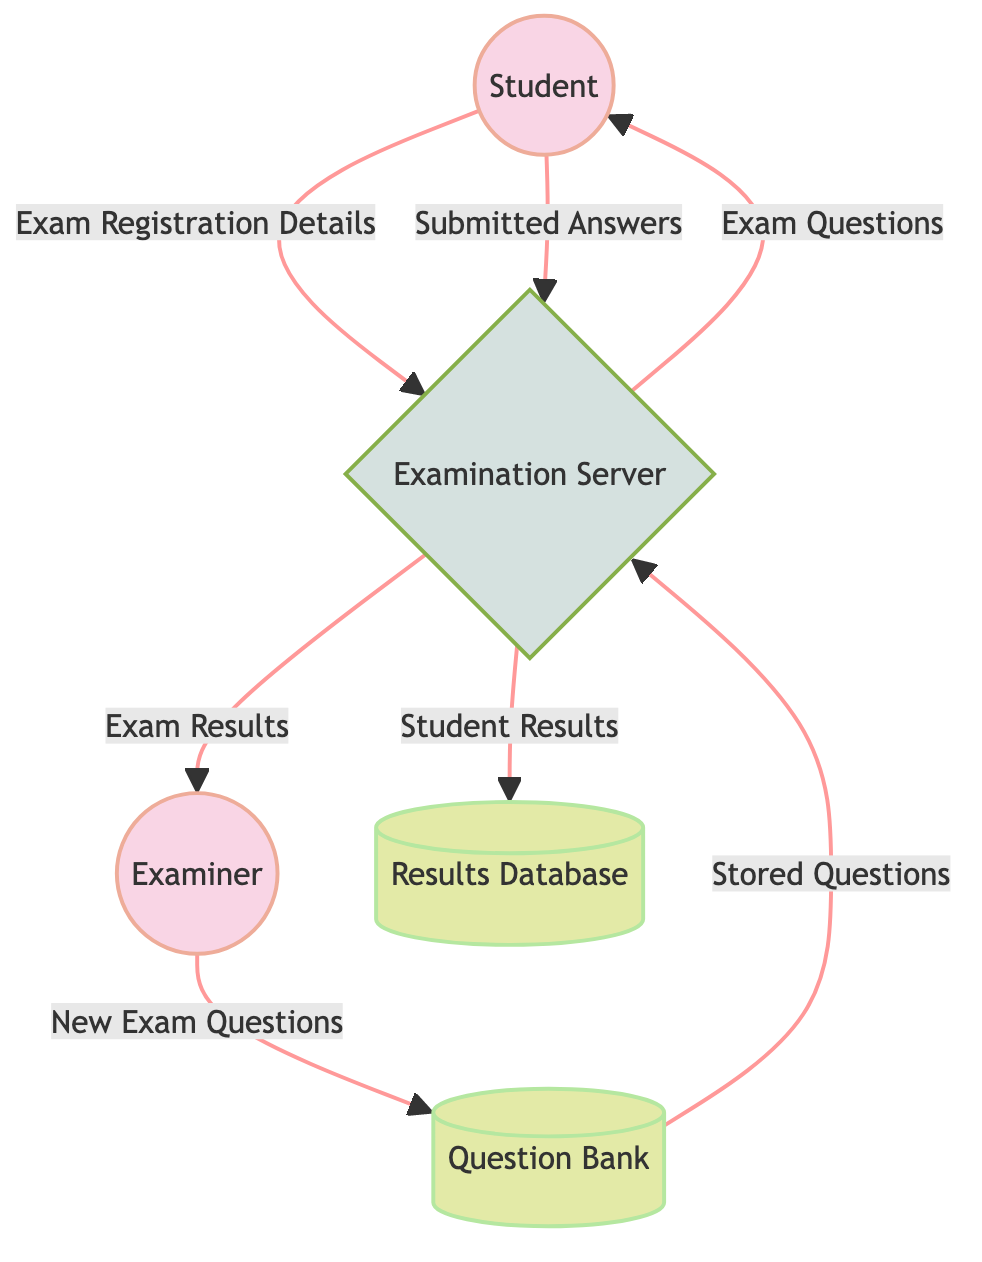What is the total number of external entities in the diagram? There are two external entities in the diagram: "Student" and "Examiner". These are distinctly marked in the diagram and fall under the category of external entities.
Answer: 2 What is the relationship between the "Examiner" and the "Question Bank"? The relationship involves the flow of "New Exam Questions" from the "Examiner" to the "Question Bank", indicating that the examiner contributes new questions.
Answer: New Exam Questions How many data flows are present in the diagram? By counting all the arrows leading from one node to another, we identify a total of six data flows in the diagram.
Answer: 6 What type of data does the "Examination Server" receive from the "Student"? The data received from the "Student" includes "Exam Registration Details" when the student registers to take the exam.
Answer: Exam Registration Details What does the "Examination Server" send to the "Results Database"? The "Examination Server" sends "Student Results" to the "Results Database" after evaluating the answers submitted by the student.
Answer: Student Results What happens to the "Stored Questions" coming from the "Question Bank"? The "Stored Questions" from the "Question Bank" are fed into the "Examination Server" for the creation of the exam, which is a critical process in the examination workflow.
Answer: Examination Server How does the "Examination Server" categorize its actions in the system? The "Examination Server" is classified as a process in this diagram, handling various activities like student registration and exam management, which is vital for the online examination system.
Answer: Process What type of node is "Results Database"? The "Results Database" is categorized as a data store in the diagram. This helps in understanding that it specifically holds results information, distinct from processes or external entities.
Answer: Data Store 